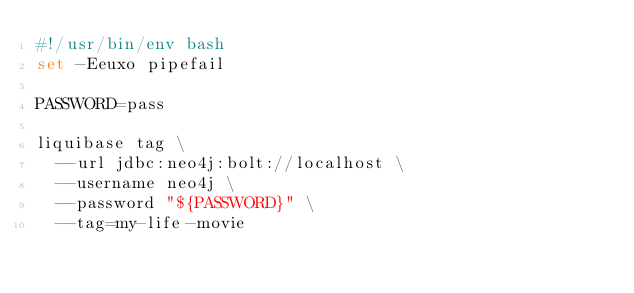Convert code to text. <code><loc_0><loc_0><loc_500><loc_500><_Bash_>#!/usr/bin/env bash
set -Eeuxo pipefail

PASSWORD=pass

liquibase tag \
	--url jdbc:neo4j:bolt://localhost \
	--username neo4j \
	--password "${PASSWORD}" \
	--tag=my-life-movie</code> 